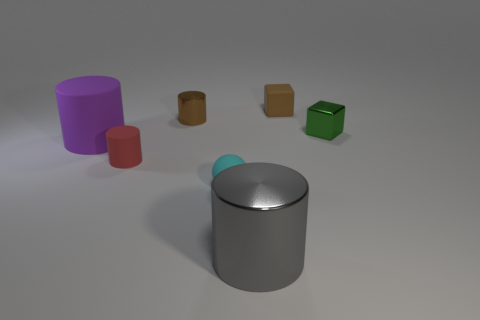What colors are the objects in the image? The objects in the image consist of a variety of colors: there is a purple cylinder, two brown cylinders, a large metallic gray cylinder, a green cube, and a small metallic ball that seems to reflect the colors around it, primarily displaying tones of gray and light blue. 